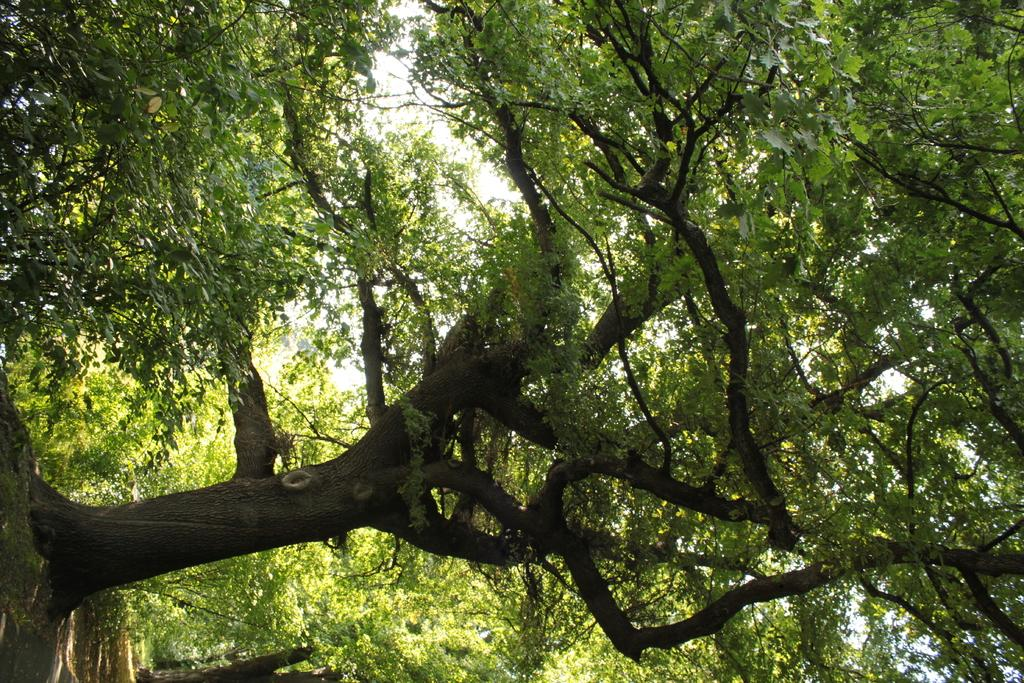What type of vegetation can be seen in the image? There are trees in the image. What part of the trees is visible in the image? The branches of the trees are visible in the image. Is there a man using a hose to water the trees in the image? There is no man or hose present in the image; it only features trees and their branches. 